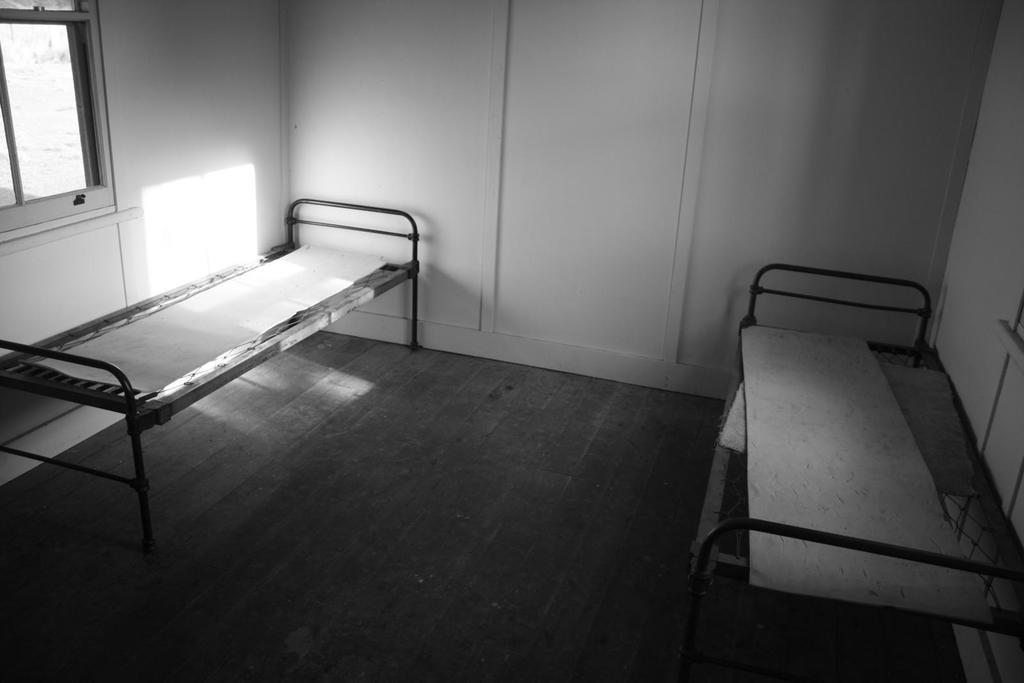What type of furniture is present in the image? There are metal beds in the image. Where are the beds located in relation to other objects? The beds are in front of a wall. Is there any source of natural light visible in the image? Yes, there is a window in the top left of the image. What type of cream can be seen being traded between the beds in the image? There is no cream or trade activity present in the image. Is there a letter visible on the wall behind the beds in the image? There is no letter visible on the wall behind the beds in the image. 